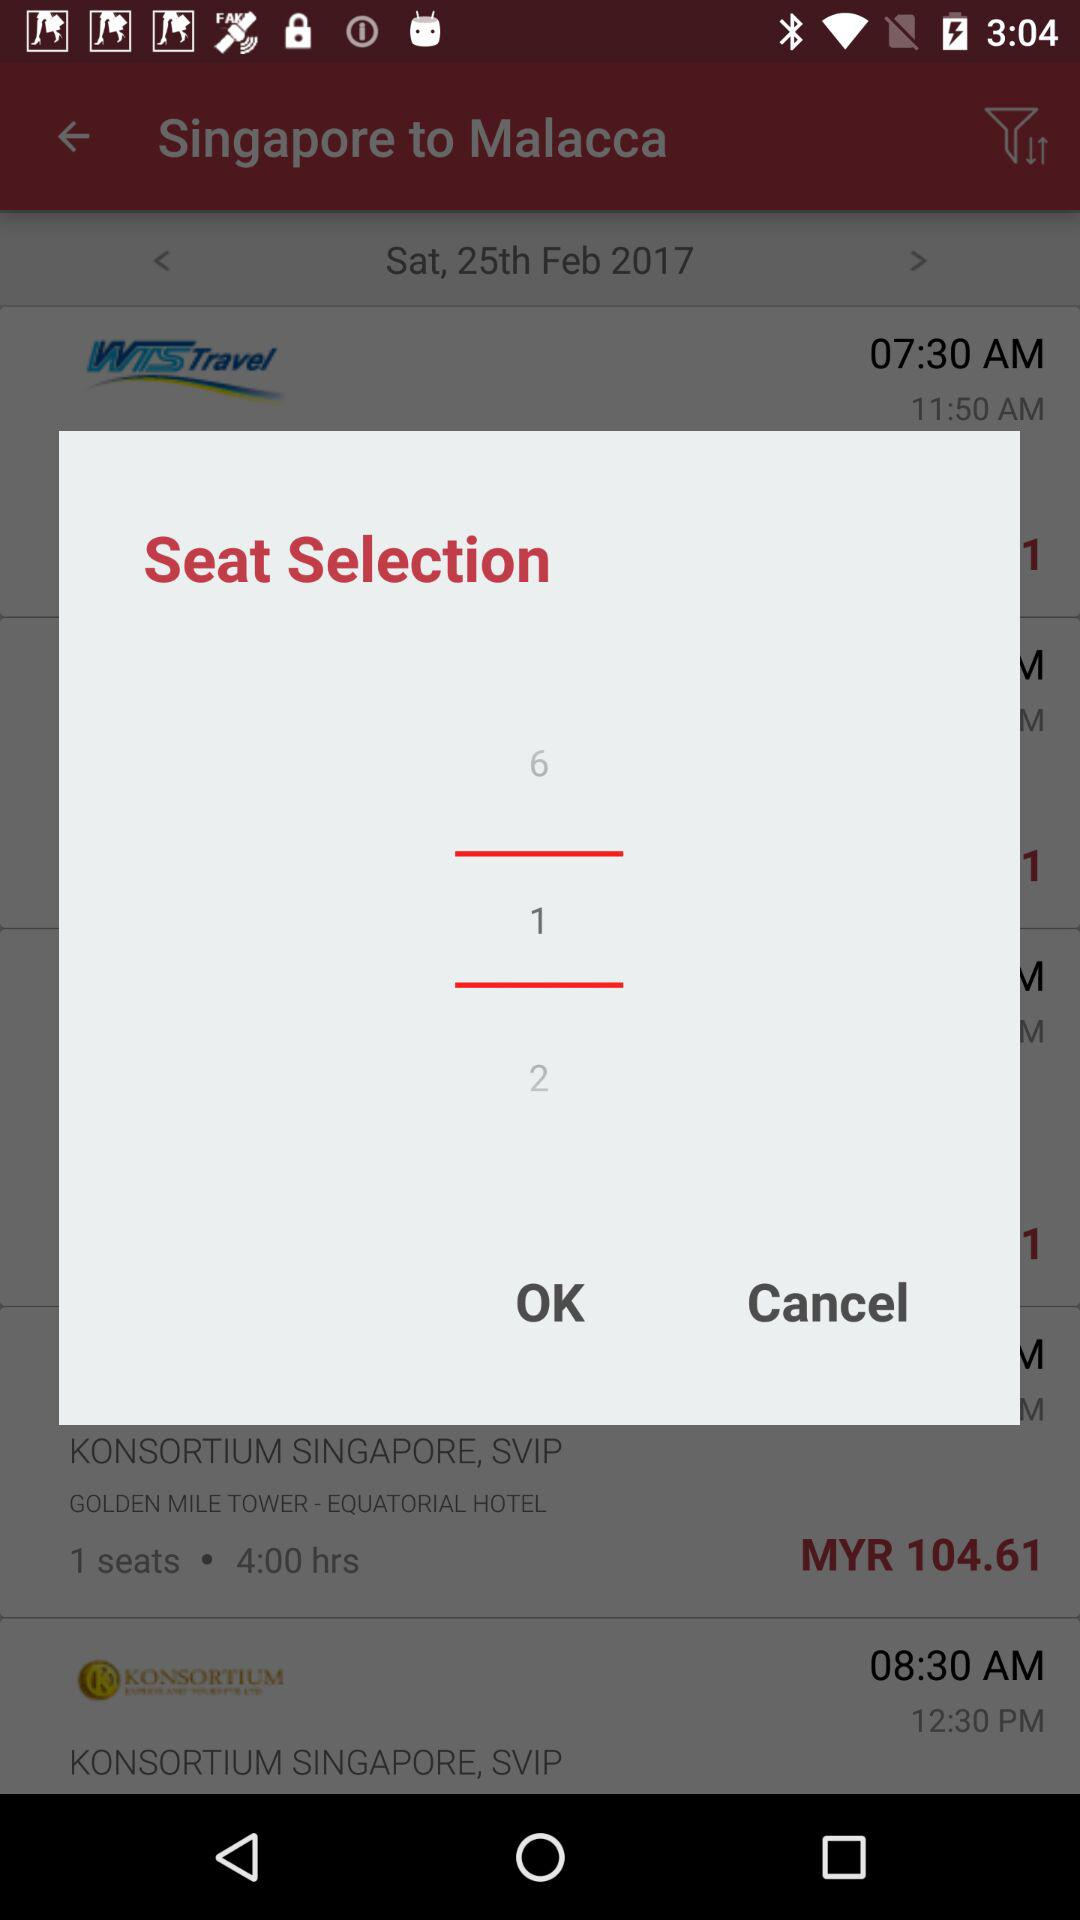How many seats are selected? There is 1 seat selected. 